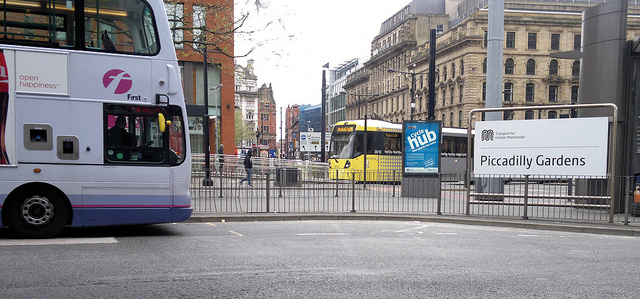Can you describe the location shown in the image? The image depicts an urban street scene that appears to be taken near Piccadilly Gardens, based on the sign in view. It's a city environment with modern architecture, and the presence of public buses suggests it's an area with accessible transportation. 